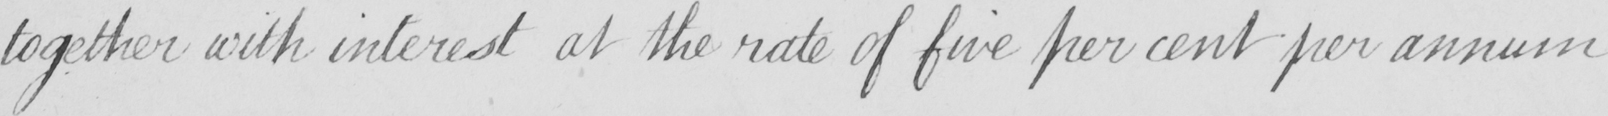Please provide the text content of this handwritten line. together with interest at the rate of five per cent per annum 